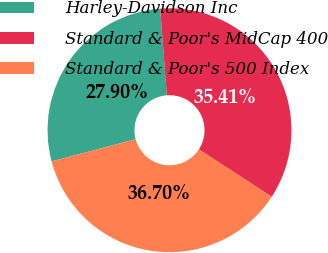Convert chart to OTSL. <chart><loc_0><loc_0><loc_500><loc_500><pie_chart><fcel>Harley-Davidson Inc<fcel>Standard & Poor's MidCap 400<fcel>Standard & Poor's 500 Index<nl><fcel>27.9%<fcel>35.41%<fcel>36.7%<nl></chart> 